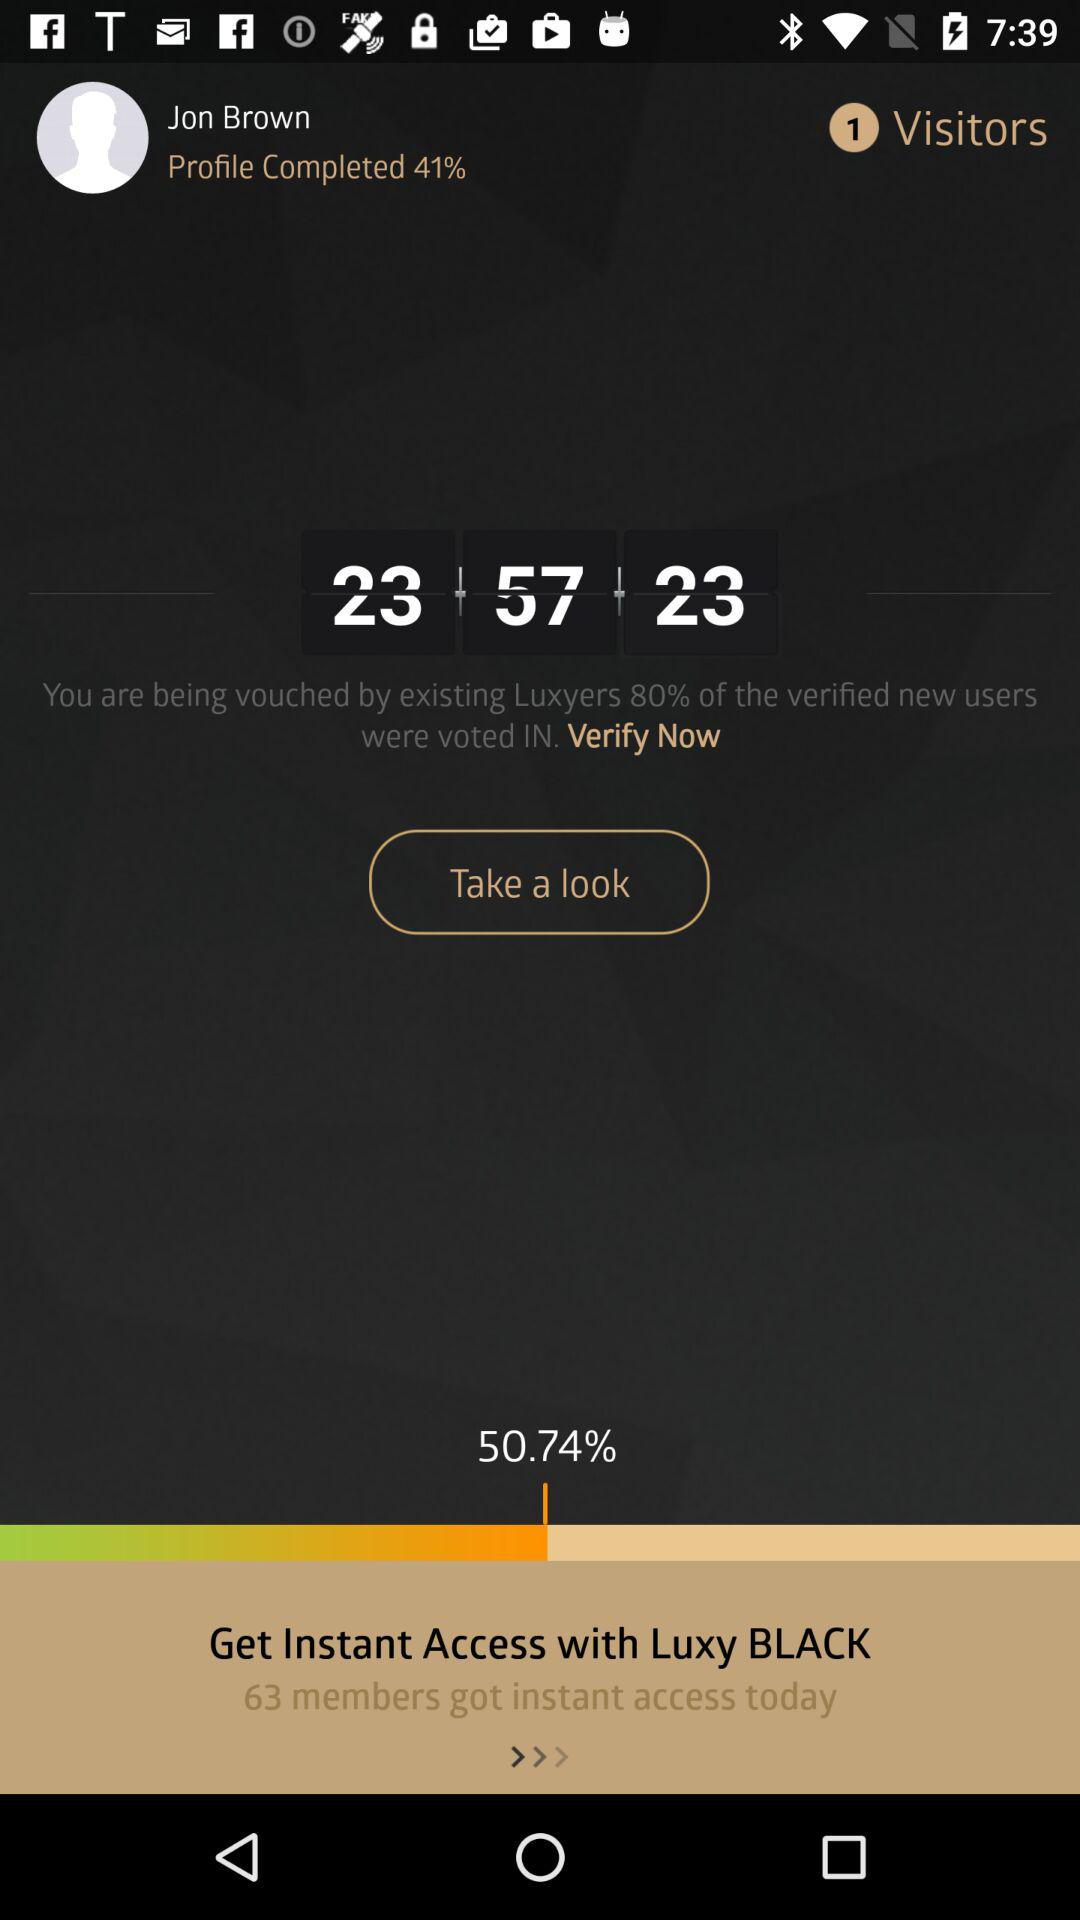How many members got instant access today?
Answer the question using a single word or phrase. 63 